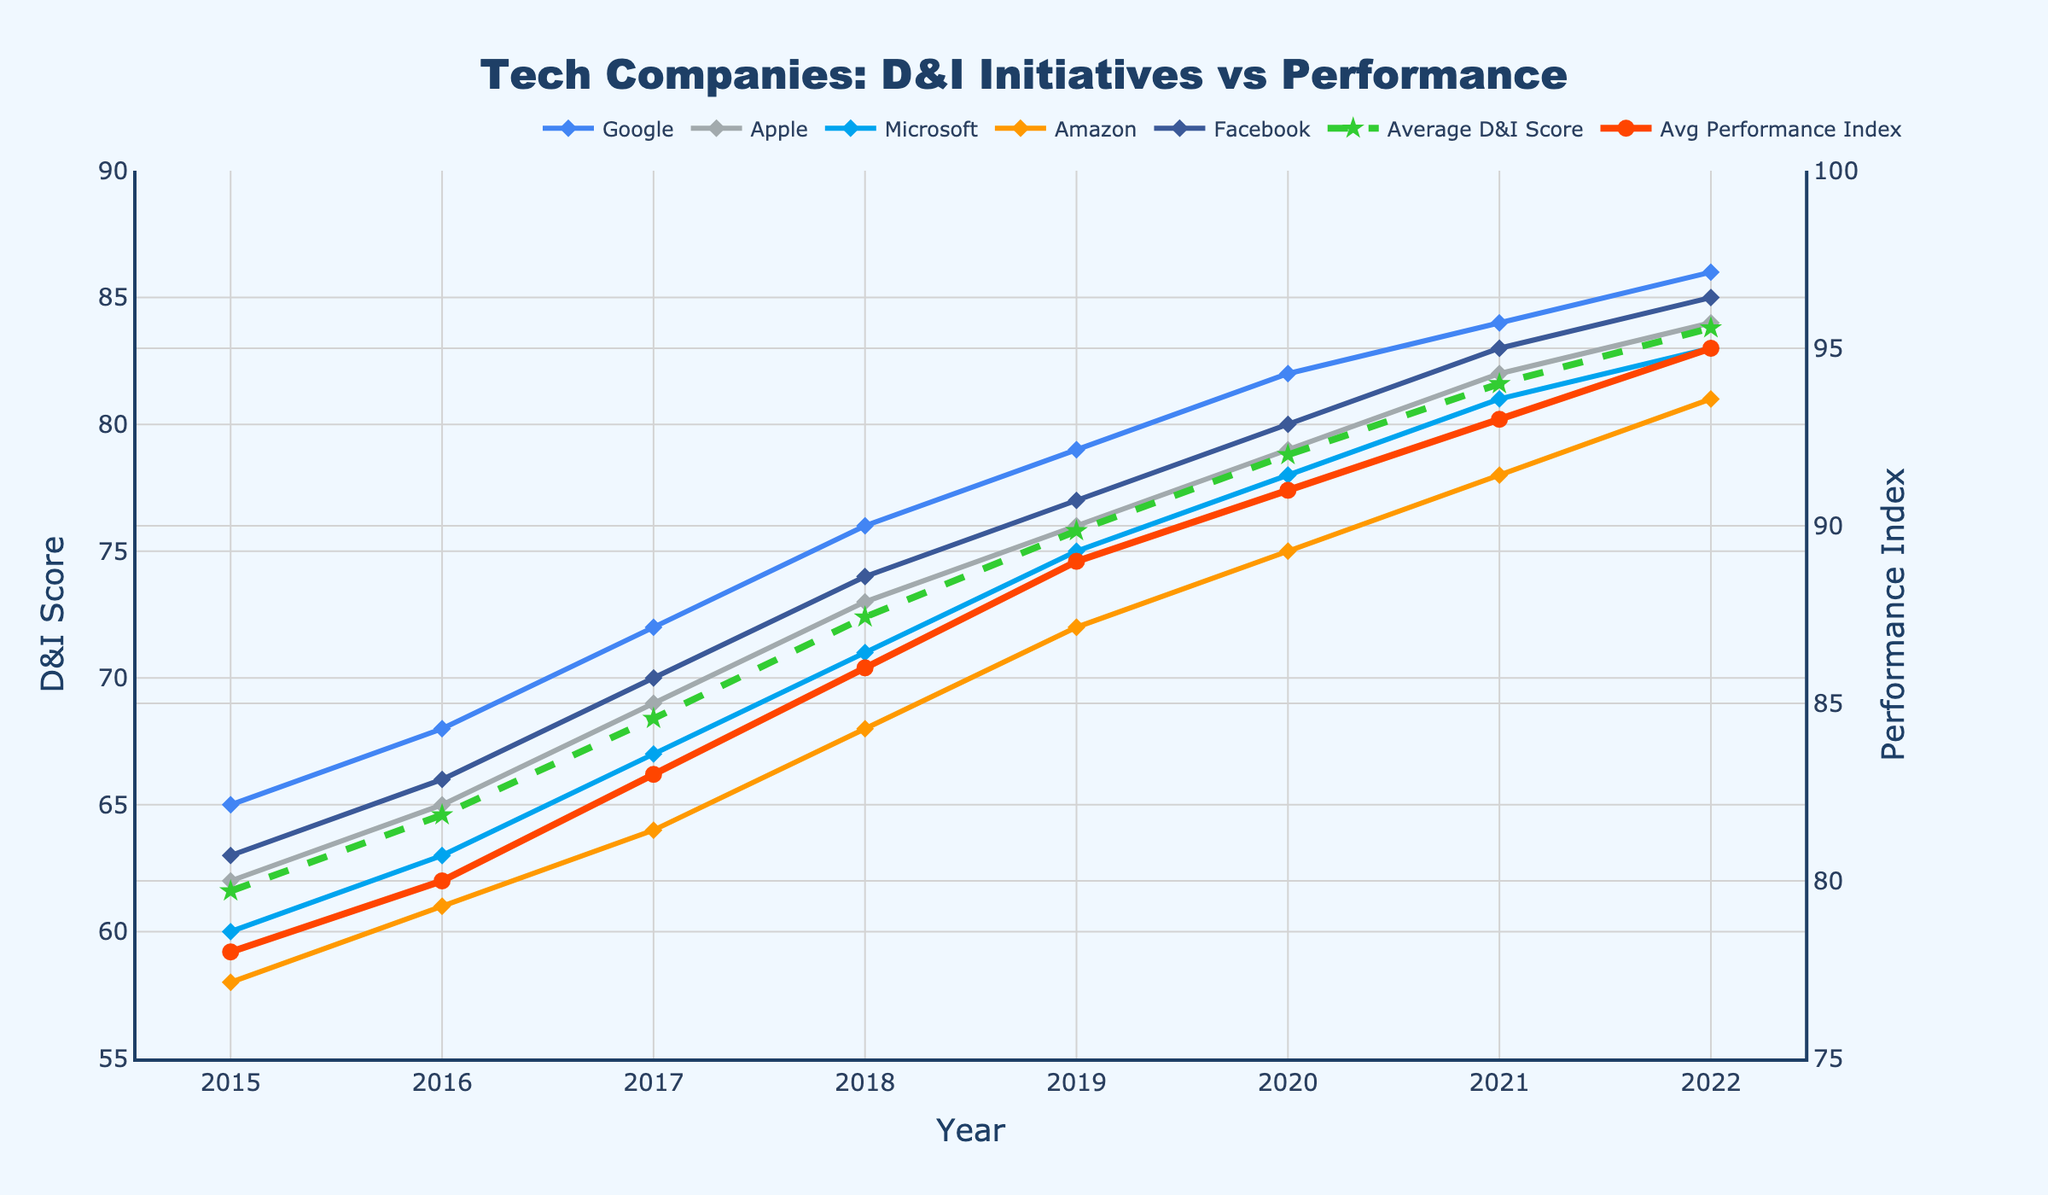What's the highest Average Tech D&I Score between 2015 and 2022? The Average Tech D&I Score increases each year and reaches its highest value in 2022, which is the last year shown.
Answer: 83.8 Which company had the lowest D&I score in 2015? In 2015, among Google, Apple, Microsoft, Amazon, and Facebook, Amazon had the lowest D&I score at 58.
Answer: Amazon By how much did the Average Tech Company Performance Index increase from 2016 to 2020? In 2016, the Performance Index was 80, and in 2020, it was 91. The increase is calculated as 91 - 80 = 11.
Answer: 11 Which two companies had equal D&I scores in 2021? In 2021, Apple and Facebook both had D&I scores of 82.
Answer: Apple and Facebook How does Google's D&I score in 2015 compare to its score in 2022? Google's D&I score in 2015 was 65, and in 2022 it increased to 86.
Answer: Google's D&I score increased by 21 points In which year did Microsoft and Google's D&I scores both surpass 70? Both Microsoft's and Google's D&I scores first surpass 70 in 2017, with Microsoft at 71 and Google at 72.
Answer: 2017 Is the Average Tech Company's D&I score higher or lower than the Average Tech Company's Performance Index in 2019? In 2019, the Average Tech D&I Score is 75.8, while the Performance Index is 89. The D&I Score is lower.
Answer: Lower Which company showed the most significant increase in D&I score from 2017 to 2020? Between 2017 and 2020, Apple's D&I score increased from 69 to 79, which is an increase of 10 points, higher than the increases for Google, Microsoft, Amazon, and Facebook.
Answer: Apple What is the difference between Facebook's D&I score and the Average Tech D&I Score in 2022? In 2022, Facebook's D&I Score is 85, and the Average Tech D&I Score is 83.8. The difference is calculated as 85 - 83.8 = 1.2.
Answer: 1.2 